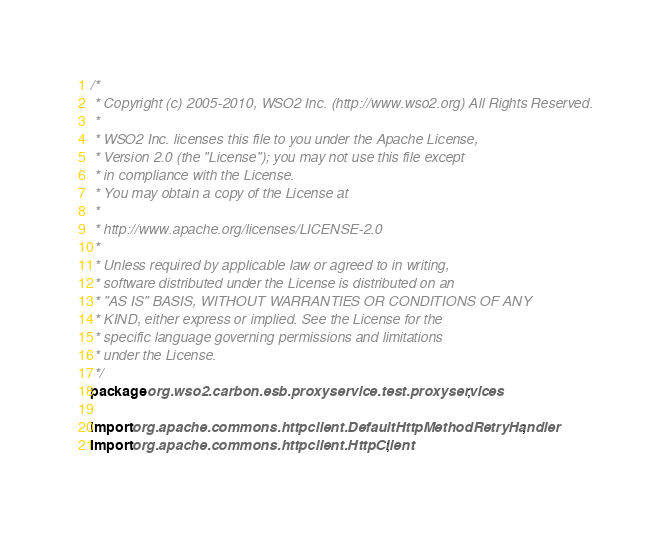Convert code to text. <code><loc_0><loc_0><loc_500><loc_500><_Java_>/*
 * Copyright (c) 2005-2010, WSO2 Inc. (http://www.wso2.org) All Rights Reserved.
 * 
 * WSO2 Inc. licenses this file to you under the Apache License,
 * Version 2.0 (the "License"); you may not use this file except
 * in compliance with the License.
 * You may obtain a copy of the License at
 * 
 * http://www.apache.org/licenses/LICENSE-2.0
 * 
 * Unless required by applicable law or agreed to in writing,
 * software distributed under the License is distributed on an
 * "AS IS" BASIS, WITHOUT WARRANTIES OR CONDITIONS OF ANY
 * KIND, either express or implied. See the License for the
 * specific language governing permissions and limitations
 * under the License.
 */
package org.wso2.carbon.esb.proxyservice.test.proxyservices;

import org.apache.commons.httpclient.DefaultHttpMethodRetryHandler;
import org.apache.commons.httpclient.HttpClient;</code> 